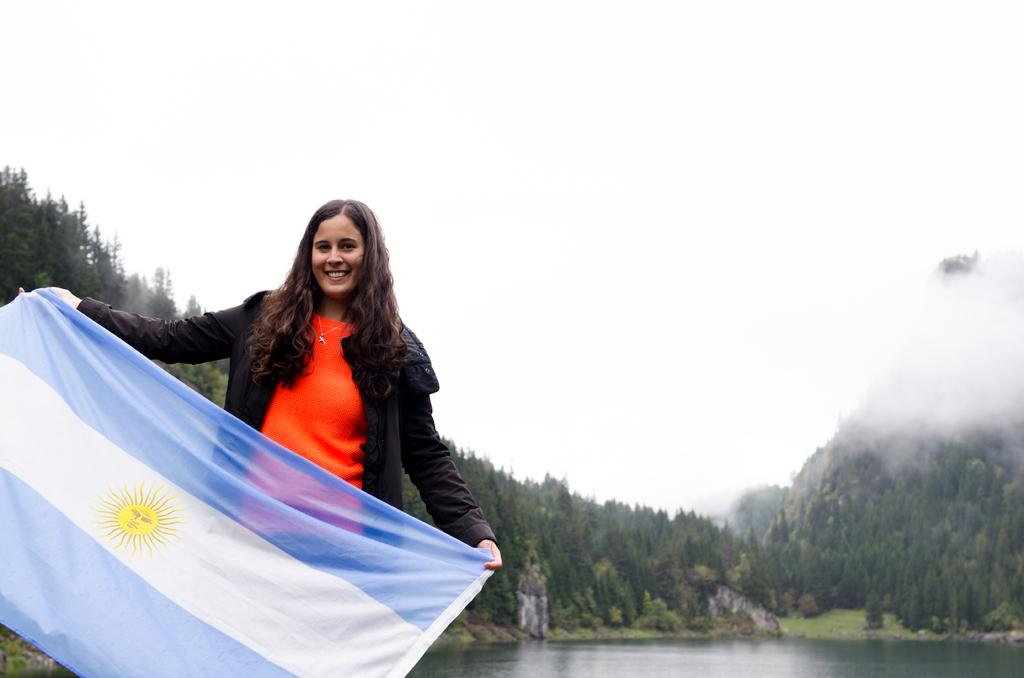What is the woman doing on the left side of the image? The woman is holding a flag and watching and smiling. What can be seen in the background of the image? There are trees, water, hills, fog, and the sky visible in the background of the image. Reasoning: Let' Let's think step by step in order to produce the conversation. We start by identifying the main subject in the image, which is the woman. Then, we describe her actions and the object she is holding, which is the flag. Next, we expand the conversation to include the background of the image, mentioning the various elements that can be seen. Each question is designed to elicit a specific detail about the image that is known from the provided facts. Absurd Question/Answer: What type of tin can be seen in the woman's hand in the image? There is no tin present in the image; the woman is holding a flag. 